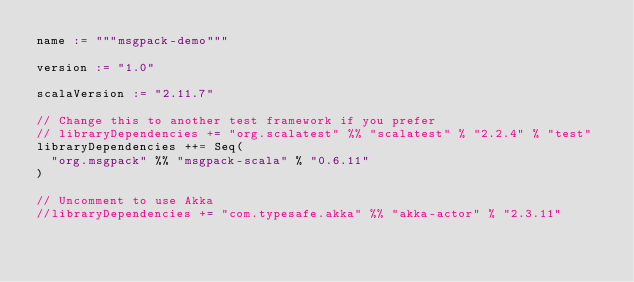Convert code to text. <code><loc_0><loc_0><loc_500><loc_500><_Scala_>name := """msgpack-demo"""

version := "1.0"

scalaVersion := "2.11.7"

// Change this to another test framework if you prefer
// libraryDependencies += "org.scalatest" %% "scalatest" % "2.2.4" % "test"
libraryDependencies ++= Seq(
  "org.msgpack" %% "msgpack-scala" % "0.6.11"
)

// Uncomment to use Akka
//libraryDependencies += "com.typesafe.akka" %% "akka-actor" % "2.3.11"
</code> 